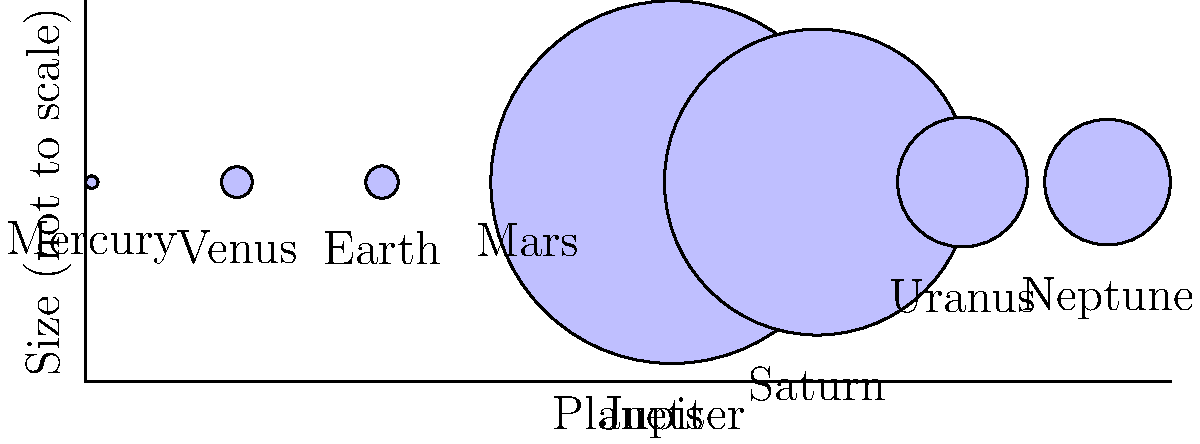As a waiter passionate about recommending hidden gems, you often engage customers in various topics. Today, an influencer asks about astronomy. Looking at this diagram of planet sizes (not to scale), which planet would you confidently state is the largest in our solar system? To determine the largest planet in our solar system, let's analyze the diagram step-by-step:

1. The diagram shows eight circles representing the planets in our solar system.
2. Each circle's size is proportional to the planet's diameter, though not to scale.
3. The planets are arranged in order from left to right: Mercury, Venus, Earth, Mars, Jupiter, Saturn, Uranus, and Neptune.
4. We can clearly see that one planet stands out as significantly larger than the others.
5. This largest circle corresponds to Jupiter, the fifth planet from the Sun.
6. Jupiter's actual diameter is approximately 142,984 km, making it the largest planet in our solar system.
7. The next largest planet, Saturn, has a diameter of about 120,536 km, which is noticeably smaller than Jupiter.
8. All other planets are considerably smaller than Jupiter and Saturn.

Therefore, based on this diagram and our knowledge of the solar system, we can confidently state that Jupiter is the largest planet.
Answer: Jupiter 